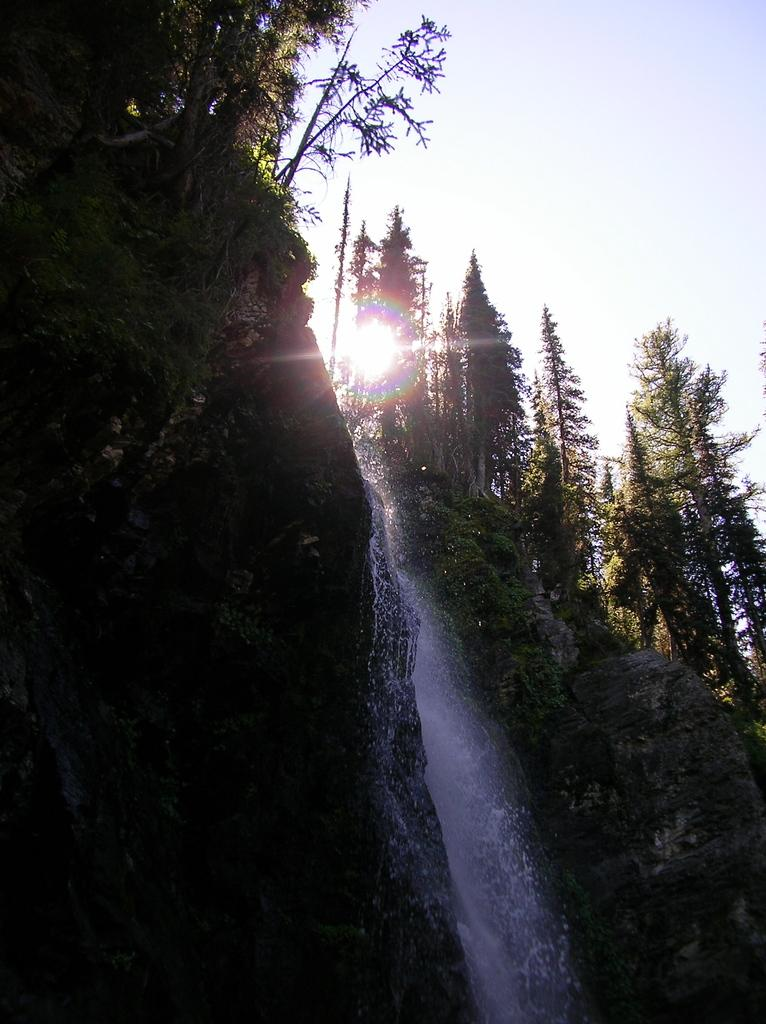What type of geographical features are present in the image? There are two rock hills and a waterfall in the image. What is growing on top of the hills? There are trees on top of the hills. What can be seen in the sky in the image? The sky is visible in the image, and there is a sunrise. How many rock hills are there in the image? There are two rock hills in the image. Where is the alley located in the image? There is no alley present in the image. What type of match is being played in the image? There is no match or game being played in the image. 